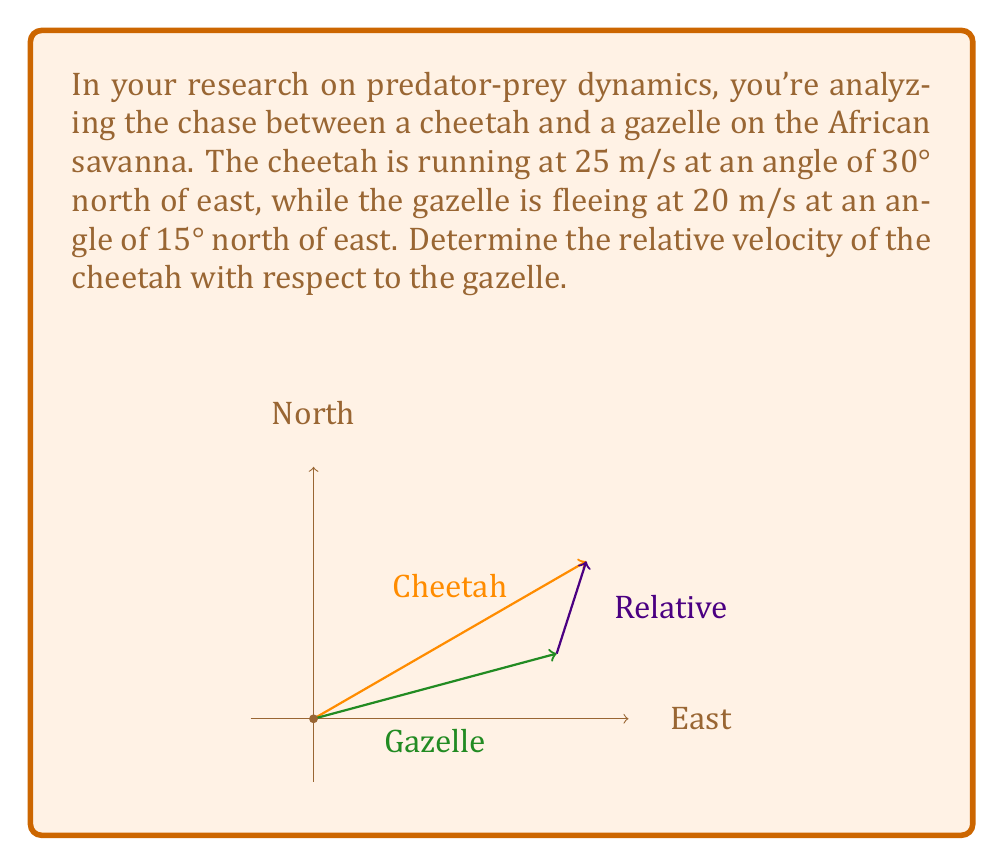Provide a solution to this math problem. To solve this problem, we need to follow these steps:

1) First, let's break down the velocities into their x and y components:

   Cheetah:
   $$v_{cx} = 25 \cos 30° = 25 \cdot \frac{\sqrt{3}}{2} = 21.65 \text{ m/s}$$
   $$v_{cy} = 25 \sin 30° = 25 \cdot \frac{1}{2} = 12.5 \text{ m/s}$$

   Gazelle:
   $$v_{gx} = 20 \cos 15° = 20 \cdot 0.9659 = 19.32 \text{ m/s}$$
   $$v_{gy} = 20 \sin 15° = 20 \cdot 0.2588 = 5.18 \text{ m/s}$$

2) The relative velocity is the difference between the cheetah's and gazelle's velocities:

   $$v_{rx} = v_{cx} - v_{gx} = 21.65 - 19.32 = 2.33 \text{ m/s}$$
   $$v_{ry} = v_{cy} - v_{gy} = 12.5 - 5.18 = 7.32 \text{ m/s}$$

3) Now we can calculate the magnitude of the relative velocity using the Pythagorean theorem:

   $$|\vec{v_r}| = \sqrt{v_{rx}^2 + v_{ry}^2} = \sqrt{2.33^2 + 7.32^2} = 7.68 \text{ m/s}$$

4) To find the direction, we use the arctangent function:

   $$\theta = \tan^{-1}\left(\frac{v_{ry}}{v_{rx}}\right) = \tan^{-1}\left(\frac{7.32}{2.33}\right) = 72.3°$$

Therefore, the relative velocity of the cheetah with respect to the gazelle is 7.68 m/s at an angle of 72.3° north of east.
Answer: 7.68 m/s, 72.3° north of east 